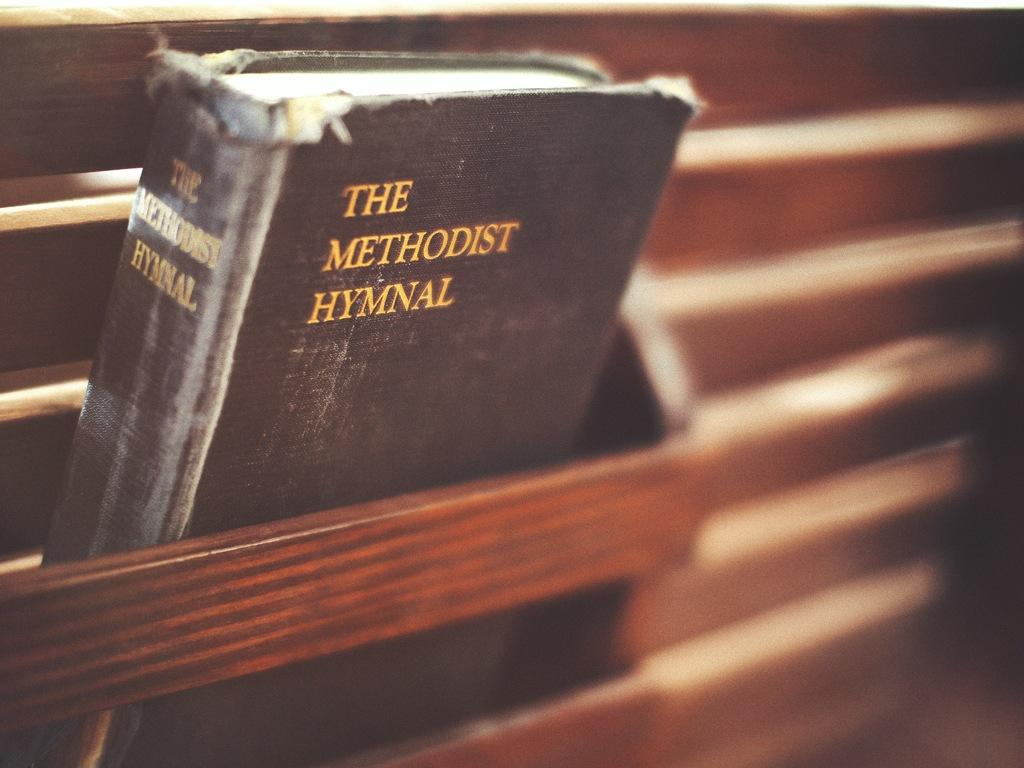<image>
Describe the image concisely. A worn copy of the Methodist Hymnal rests in a pew. 